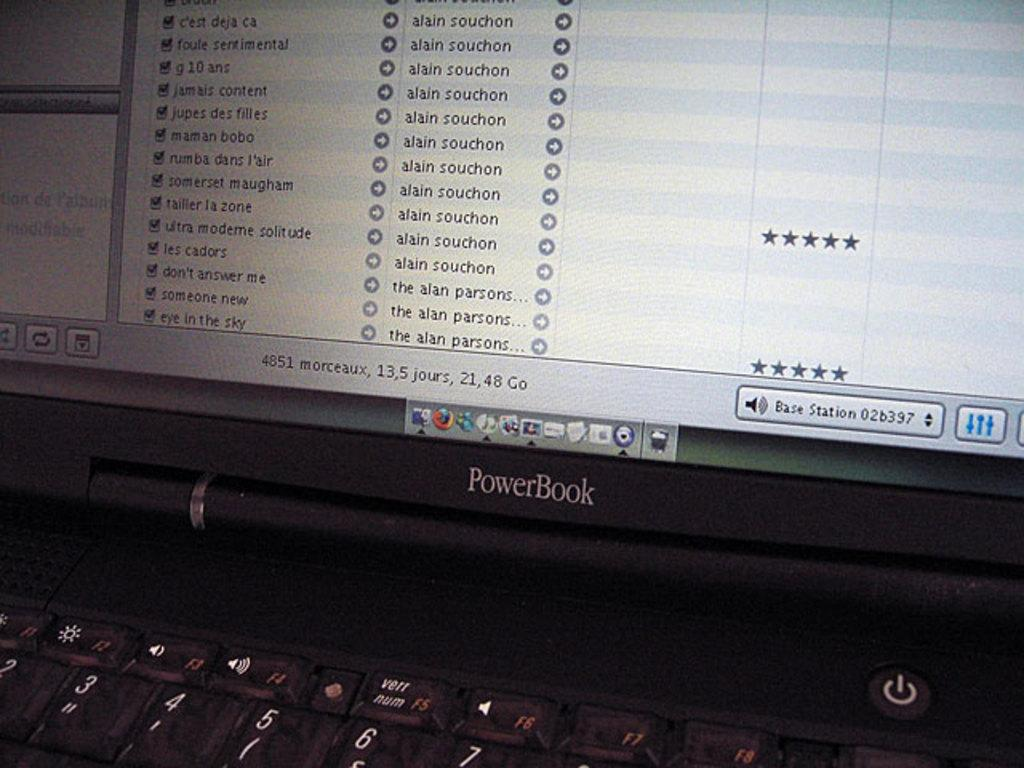What electronic device is present in the image? There is a laptop in the image. What is visible on the laptop screen? There are apps visible on the laptop screen. What type of soup is being served in the image? There is no soup present in the image; it features a laptop with apps on the screen. What kind of jam is visible on the laptop screen? There is no jam present in the image; it features a laptop with apps on the screen. 